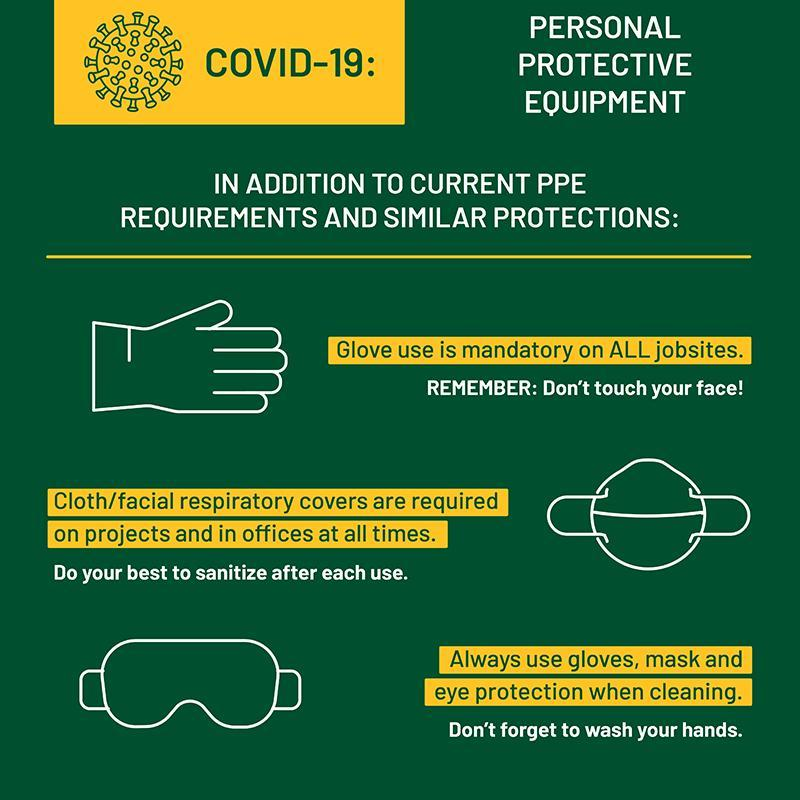In addition to the current PPE, what are the other protective wear to be used?
Answer the question with a short phrase. Gloves, mask and eye protection 